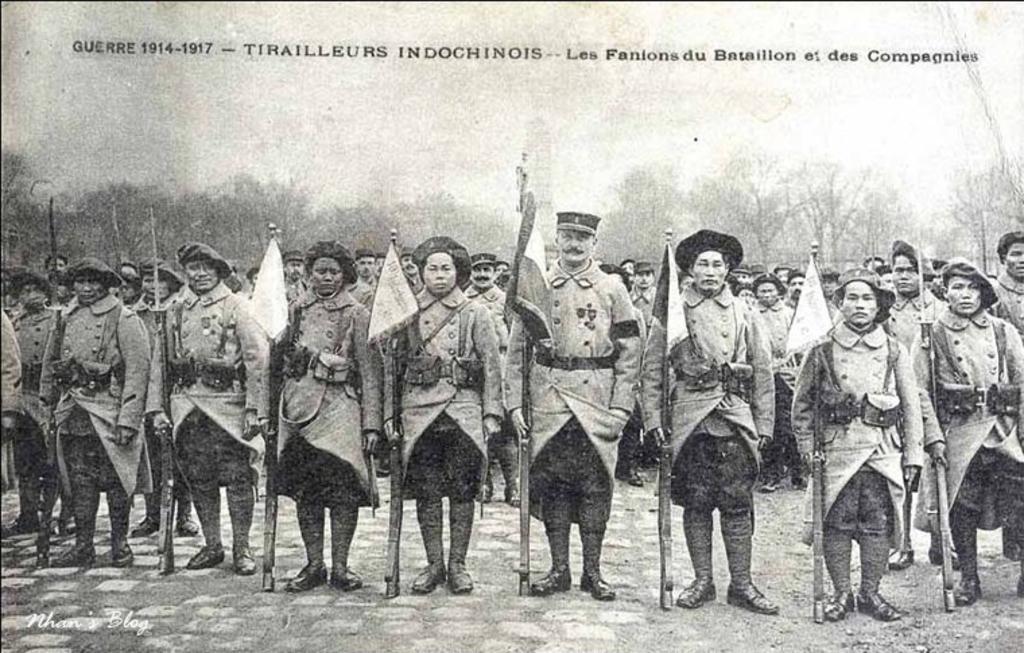In one or two sentences, can you explain what this image depicts? In this image I can see a group of people are standing on the road and are holding guns in their hand and flags. In the background I can see trees, the sky and a text. This image is taken may be in the forest. 